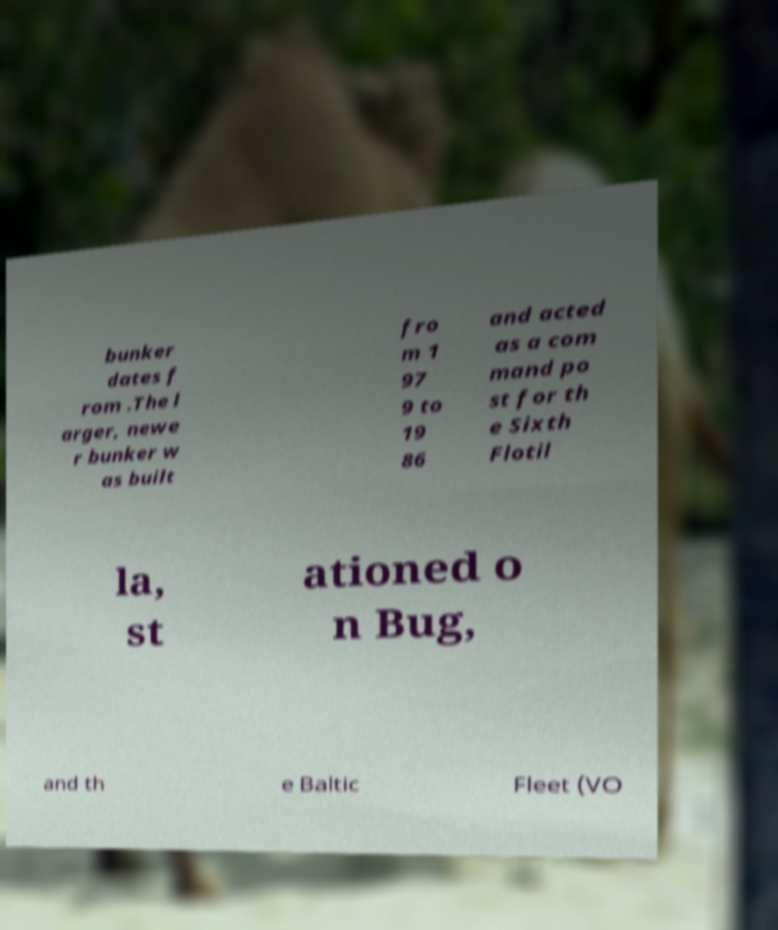Please identify and transcribe the text found in this image. bunker dates f rom .The l arger, newe r bunker w as built fro m 1 97 9 to 19 86 and acted as a com mand po st for th e Sixth Flotil la, st ationed o n Bug, and th e Baltic Fleet (VO 